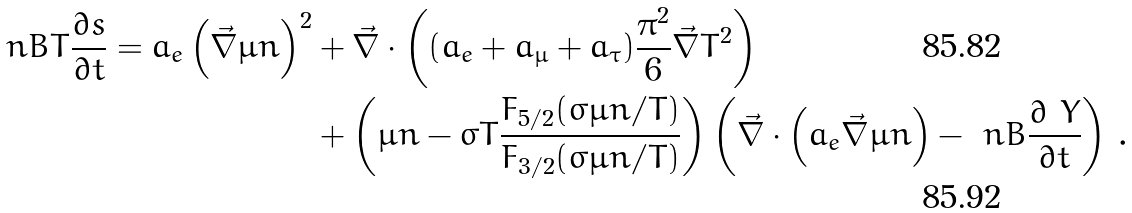Convert formula to latex. <formula><loc_0><loc_0><loc_500><loc_500>\ n B T \frac { \partial s } { \partial t } = a _ { e } \left ( \vec { \nabla } \mu n \right ) ^ { 2 } & + \vec { \nabla } \cdot \left ( ( a _ { e } + a _ { \mu } + a _ { \tau } ) \frac { \pi ^ { 2 } } { 6 } \vec { \nabla } T ^ { 2 } \right ) \\ & + \left ( \mu n - \sigma T \frac { F _ { 5 / 2 } ( \sigma \mu n / T ) } { F _ { 3 / 2 } ( \sigma \mu n / T ) } \right ) \left ( \vec { \nabla } \cdot \left ( a _ { e } \vec { \nabla } \mu n \right ) - \ n B \frac { \partial \ Y } { \partial t } \right ) \, .</formula> 